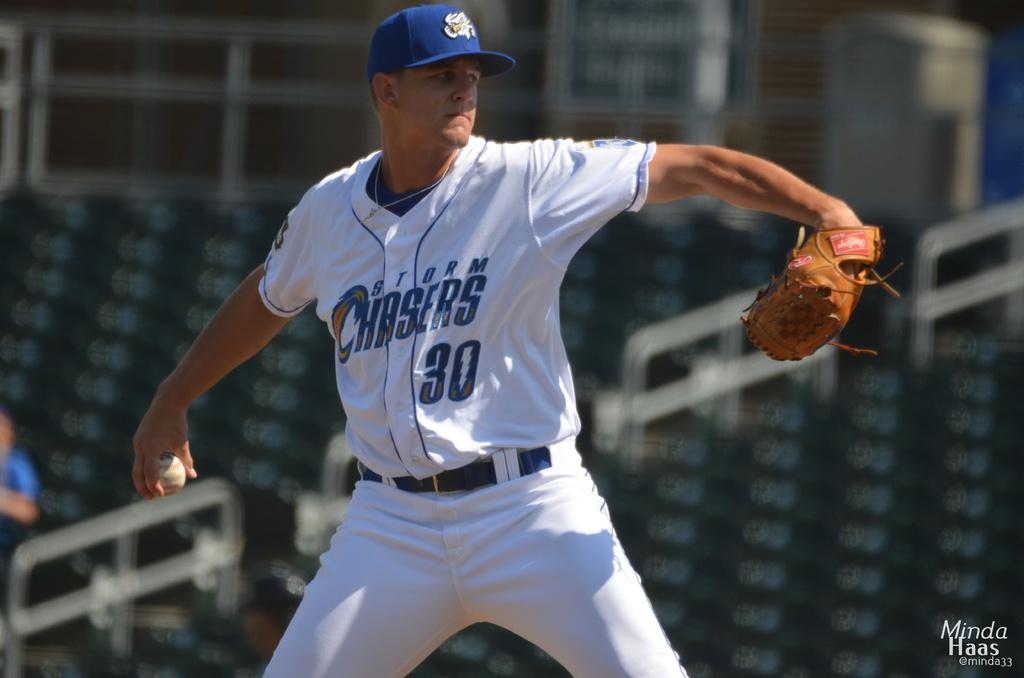<image>
Render a clear and concise summary of the photo. The baseball player whose number is 30 ready to throw the ball 